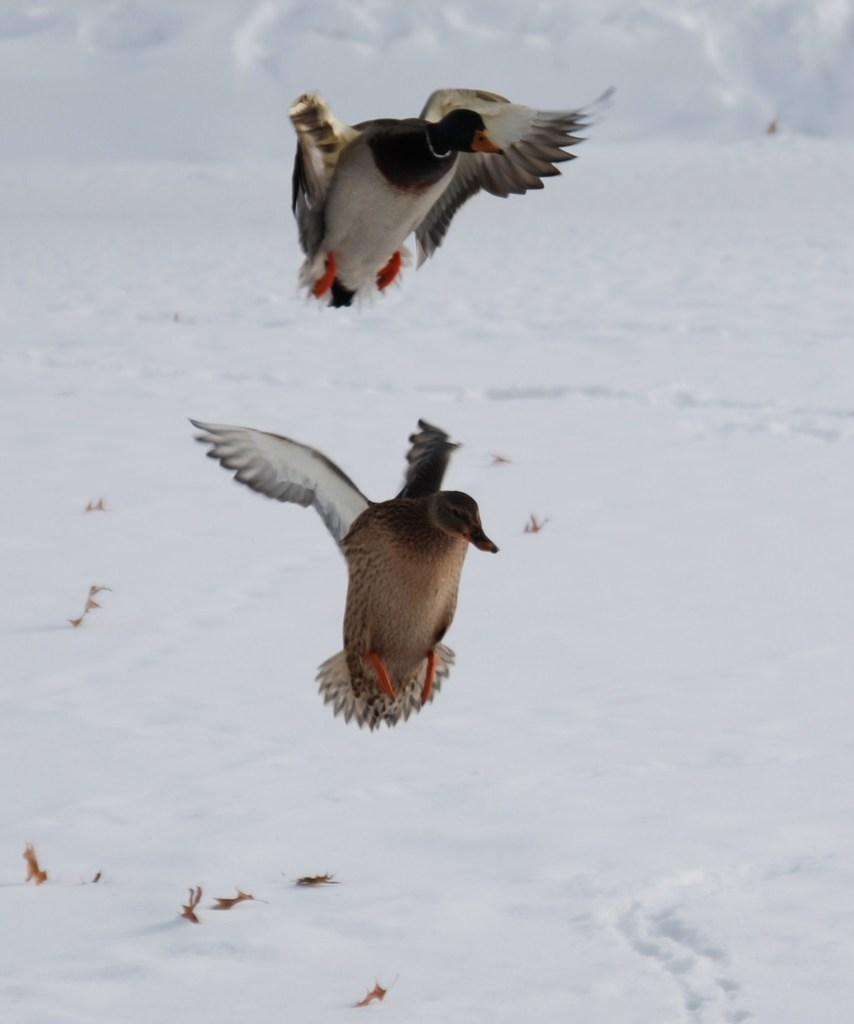How many birds are visible in the image? There are two birds in the image. What is the ground covered with in the image? There is snow in the image. Can you determine the time of day the image was taken? The image was likely taken during the day, as there is sufficient light to see the birds and snow clearly. What type of beast can be seen drinking from the basin in the image? There is no basin or beast present in the image; it features two birds in a snowy environment. 